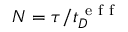<formula> <loc_0><loc_0><loc_500><loc_500>{ N } = \tau / t _ { D } ^ { e f f }</formula> 